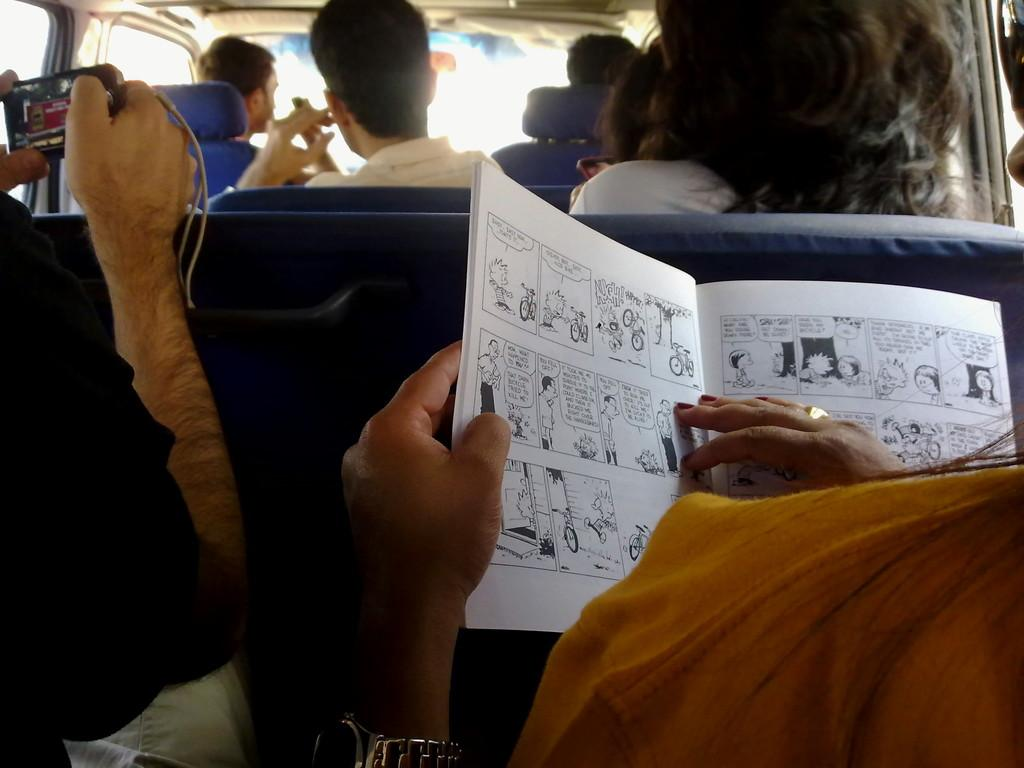How many people are in the image? There are people in the image, but the exact number is not specified. What are the people wearing in the image? The people in the image are wearing clothes. What accessories can be seen on the people in the image? A wrist watch and a finger ring can be seen on the people in the image. What object related to reading is present in the image? There is a book in the image. What type of electronic device is present in the image? There is a gadget in the image. What is the setting of the image? The image is an internal view of a vehicle. What type of clover is growing on the elbow of the person in the image? There is no clover present in the image, nor is there any mention of an elbow. 